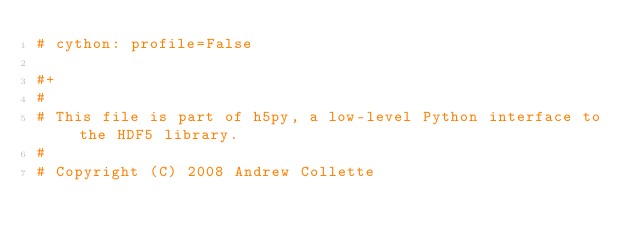<code> <loc_0><loc_0><loc_500><loc_500><_Cython_># cython: profile=False

#+
# 
# This file is part of h5py, a low-level Python interface to the HDF5 library.
# 
# Copyright (C) 2008 Andrew Collette</code> 